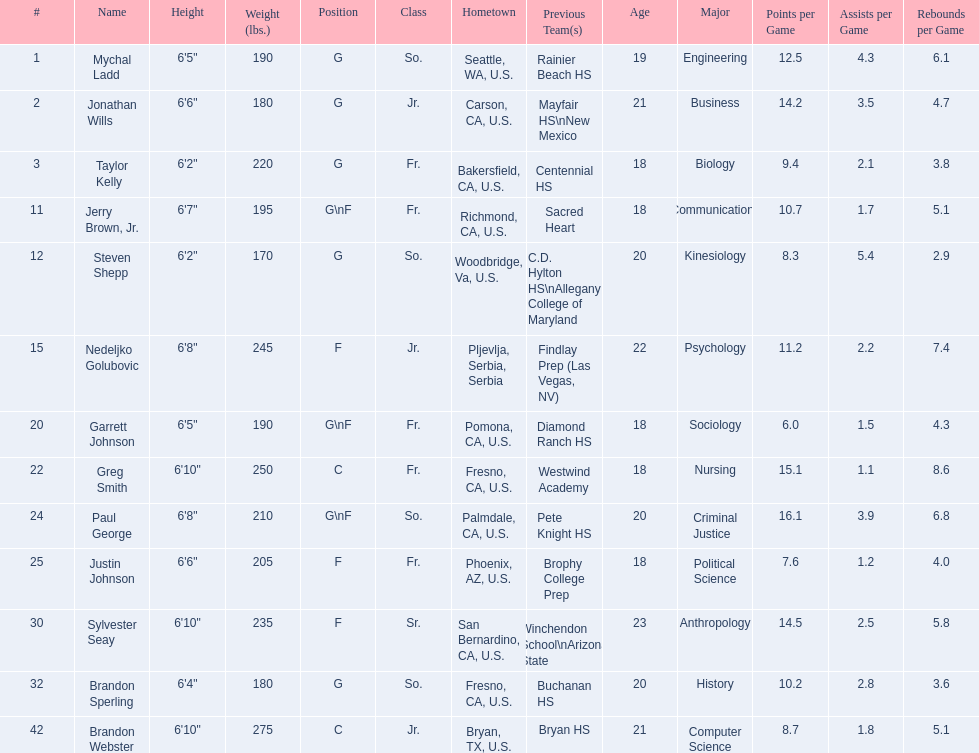Which positions are so.? G, G, G\nF, G. Which weights are g 190, 170, 180. What height is under 6 3' 6'2". Would you mind parsing the complete table? {'header': ['#', 'Name', 'Height', 'Weight (lbs.)', 'Position', 'Class', 'Hometown', 'Previous Team(s)', 'Age', 'Major', 'Points per Game', 'Assists per Game', 'Rebounds per Game'], 'rows': [['1', 'Mychal Ladd', '6\'5"', '190', 'G', 'So.', 'Seattle, WA, U.S.', 'Rainier Beach HS', '19', 'Engineering', '12.5', '4.3', '6.1'], ['2', 'Jonathan Wills', '6\'6"', '180', 'G', 'Jr.', 'Carson, CA, U.S.', 'Mayfair HS\\nNew Mexico', '21', 'Business', '14.2', '3.5', '4.7'], ['3', 'Taylor Kelly', '6\'2"', '220', 'G', 'Fr.', 'Bakersfield, CA, U.S.', 'Centennial HS', '18', 'Biology', '9.4', '2.1', '3.8'], ['11', 'Jerry Brown, Jr.', '6\'7"', '195', 'G\\nF', 'Fr.', 'Richmond, CA, U.S.', 'Sacred Heart', '18', 'Communications', '10.7', '1.7', '5.1'], ['12', 'Steven Shepp', '6\'2"', '170', 'G', 'So.', 'Woodbridge, Va, U.S.', 'C.D. Hylton HS\\nAllegany College of Maryland', '20', 'Kinesiology', '8.3', '5.4', '2.9'], ['15', 'Nedeljko Golubovic', '6\'8"', '245', 'F', 'Jr.', 'Pljevlja, Serbia, Serbia', 'Findlay Prep (Las Vegas, NV)', '22', 'Psychology', '11.2', '2.2', '7.4'], ['20', 'Garrett Johnson', '6\'5"', '190', 'G\\nF', 'Fr.', 'Pomona, CA, U.S.', 'Diamond Ranch HS', '18', 'Sociology', '6.0', '1.5', '4.3'], ['22', 'Greg Smith', '6\'10"', '250', 'C', 'Fr.', 'Fresno, CA, U.S.', 'Westwind Academy', '18', 'Nursing', '15.1', '1.1', '8.6'], ['24', 'Paul George', '6\'8"', '210', 'G\\nF', 'So.', 'Palmdale, CA, U.S.', 'Pete Knight HS', '20', 'Criminal Justice', '16.1', '3.9', '6.8'], ['25', 'Justin Johnson', '6\'6"', '205', 'F', 'Fr.', 'Phoenix, AZ, U.S.', 'Brophy College Prep', '18', 'Political Science', '7.6', '1.2', '4.0'], ['30', 'Sylvester Seay', '6\'10"', '235', 'F', 'Sr.', 'San Bernardino, CA, U.S.', 'Winchendon School\\nArizona State', '23', 'Anthropology', '14.5', '2.5', '5.8'], ['32', 'Brandon Sperling', '6\'4"', '180', 'G', 'So.', 'Fresno, CA, U.S.', 'Buchanan HS', '20', 'History', '10.2', '2.8', '3.6'], ['42', 'Brandon Webster', '6\'10"', '275', 'C', 'Jr.', 'Bryan, TX, U.S.', 'Bryan HS', '21', 'Computer Science', '8.7', '1.8', '5.1']]} What is the name Steven Shepp. 